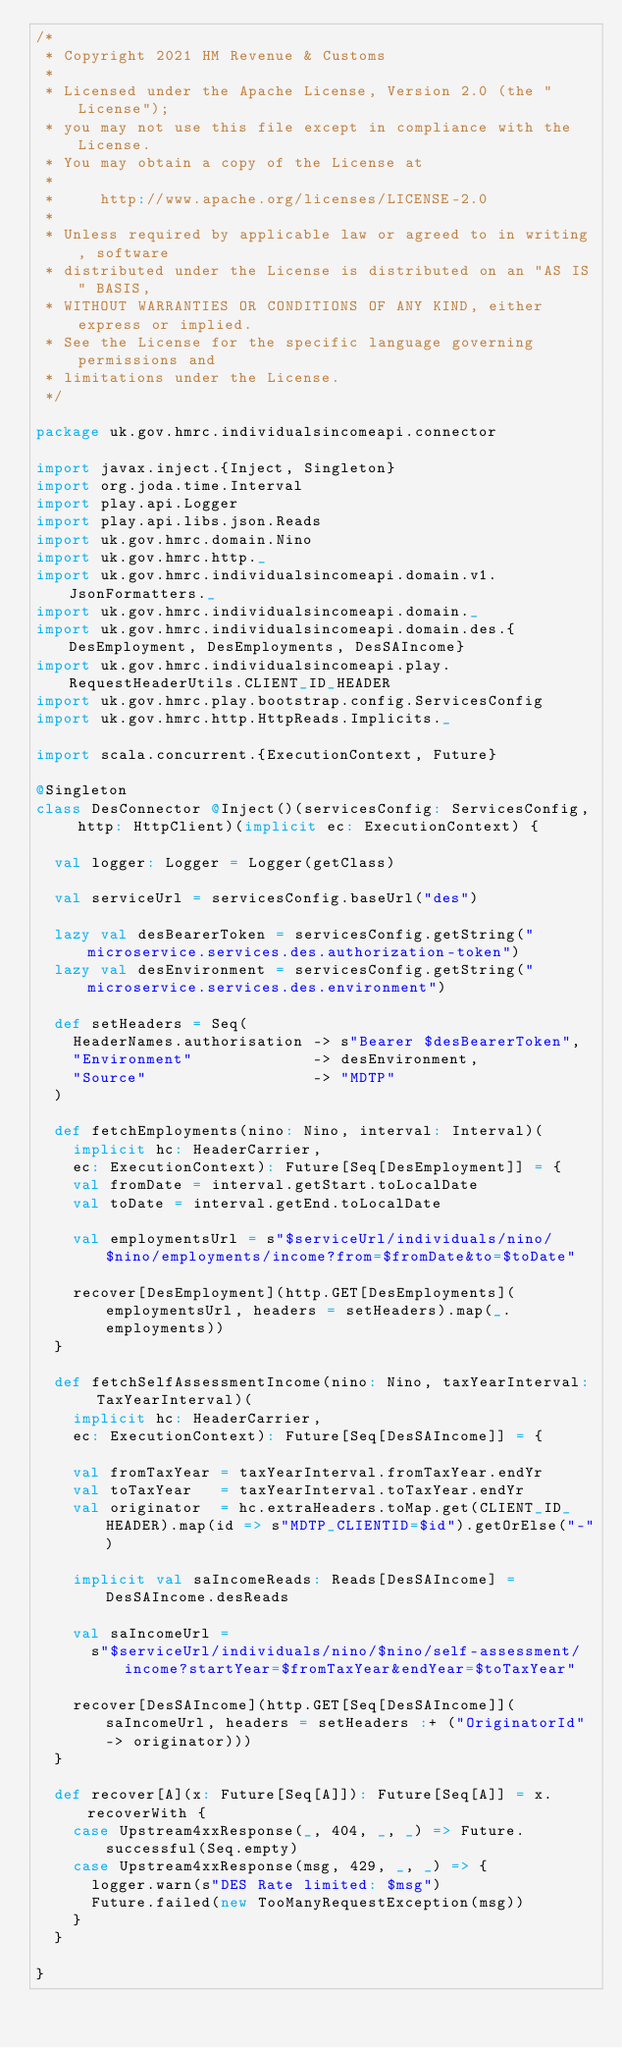Convert code to text. <code><loc_0><loc_0><loc_500><loc_500><_Scala_>/*
 * Copyright 2021 HM Revenue & Customs
 *
 * Licensed under the Apache License, Version 2.0 (the "License");
 * you may not use this file except in compliance with the License.
 * You may obtain a copy of the License at
 *
 *     http://www.apache.org/licenses/LICENSE-2.0
 *
 * Unless required by applicable law or agreed to in writing, software
 * distributed under the License is distributed on an "AS IS" BASIS,
 * WITHOUT WARRANTIES OR CONDITIONS OF ANY KIND, either express or implied.
 * See the License for the specific language governing permissions and
 * limitations under the License.
 */

package uk.gov.hmrc.individualsincomeapi.connector

import javax.inject.{Inject, Singleton}
import org.joda.time.Interval
import play.api.Logger
import play.api.libs.json.Reads
import uk.gov.hmrc.domain.Nino
import uk.gov.hmrc.http._
import uk.gov.hmrc.individualsincomeapi.domain.v1.JsonFormatters._
import uk.gov.hmrc.individualsincomeapi.domain._
import uk.gov.hmrc.individualsincomeapi.domain.des.{DesEmployment, DesEmployments, DesSAIncome}
import uk.gov.hmrc.individualsincomeapi.play.RequestHeaderUtils.CLIENT_ID_HEADER
import uk.gov.hmrc.play.bootstrap.config.ServicesConfig
import uk.gov.hmrc.http.HttpReads.Implicits._

import scala.concurrent.{ExecutionContext, Future}

@Singleton
class DesConnector @Inject()(servicesConfig: ServicesConfig, http: HttpClient)(implicit ec: ExecutionContext) {

  val logger: Logger = Logger(getClass)

  val serviceUrl = servicesConfig.baseUrl("des")

  lazy val desBearerToken = servicesConfig.getString("microservice.services.des.authorization-token")
  lazy val desEnvironment = servicesConfig.getString("microservice.services.des.environment")

  def setHeaders = Seq(
    HeaderNames.authorisation -> s"Bearer $desBearerToken",
    "Environment"             -> desEnvironment,
    "Source"                  -> "MDTP"
  )

  def fetchEmployments(nino: Nino, interval: Interval)(
    implicit hc: HeaderCarrier,
    ec: ExecutionContext): Future[Seq[DesEmployment]] = {
    val fromDate = interval.getStart.toLocalDate
    val toDate = interval.getEnd.toLocalDate

    val employmentsUrl = s"$serviceUrl/individuals/nino/$nino/employments/income?from=$fromDate&to=$toDate"

    recover[DesEmployment](http.GET[DesEmployments](employmentsUrl, headers = setHeaders).map(_.employments))
  }

  def fetchSelfAssessmentIncome(nino: Nino, taxYearInterval: TaxYearInterval)(
    implicit hc: HeaderCarrier,
    ec: ExecutionContext): Future[Seq[DesSAIncome]] = {

    val fromTaxYear = taxYearInterval.fromTaxYear.endYr
    val toTaxYear   = taxYearInterval.toTaxYear.endYr
    val originator  = hc.extraHeaders.toMap.get(CLIENT_ID_HEADER).map(id => s"MDTP_CLIENTID=$id").getOrElse("-")

    implicit val saIncomeReads: Reads[DesSAIncome] = DesSAIncome.desReads

    val saIncomeUrl =
      s"$serviceUrl/individuals/nino/$nino/self-assessment/income?startYear=$fromTaxYear&endYear=$toTaxYear"

    recover[DesSAIncome](http.GET[Seq[DesSAIncome]](saIncomeUrl, headers = setHeaders :+ ("OriginatorId" -> originator)))
  }

  def recover[A](x: Future[Seq[A]]): Future[Seq[A]] = x.recoverWith {
    case Upstream4xxResponse(_, 404, _, _) => Future.successful(Seq.empty)
    case Upstream4xxResponse(msg, 429, _, _) => {
      logger.warn(s"DES Rate limited: $msg")
      Future.failed(new TooManyRequestException(msg))
    }
  }

}
</code> 